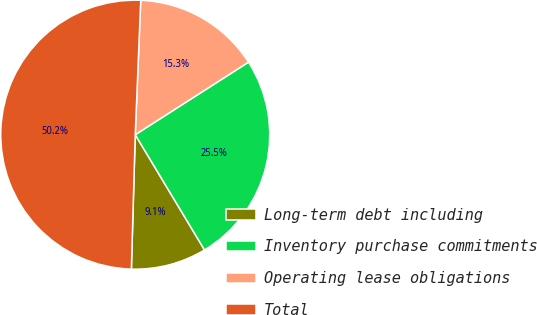Convert chart to OTSL. <chart><loc_0><loc_0><loc_500><loc_500><pie_chart><fcel>Long-term debt including<fcel>Inventory purchase commitments<fcel>Operating lease obligations<fcel>Total<nl><fcel>9.07%<fcel>25.46%<fcel>15.28%<fcel>50.2%<nl></chart> 